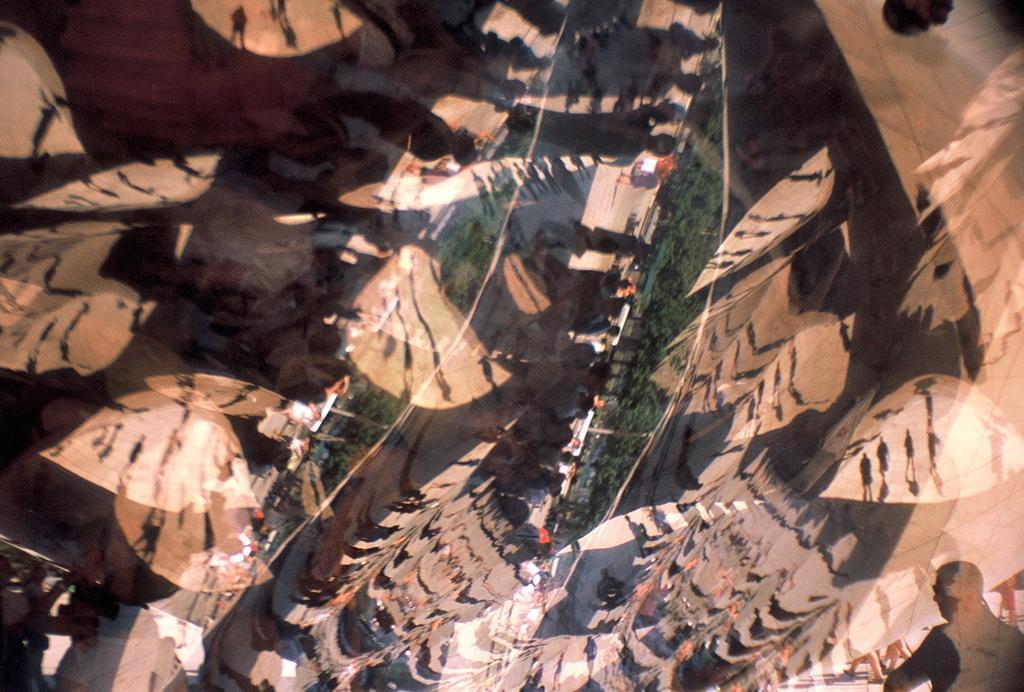In one or two sentences, can you explain what this image depicts? In this image in the foreground there is a glass door and through the door we could see reflection of some people, trees and objects. 